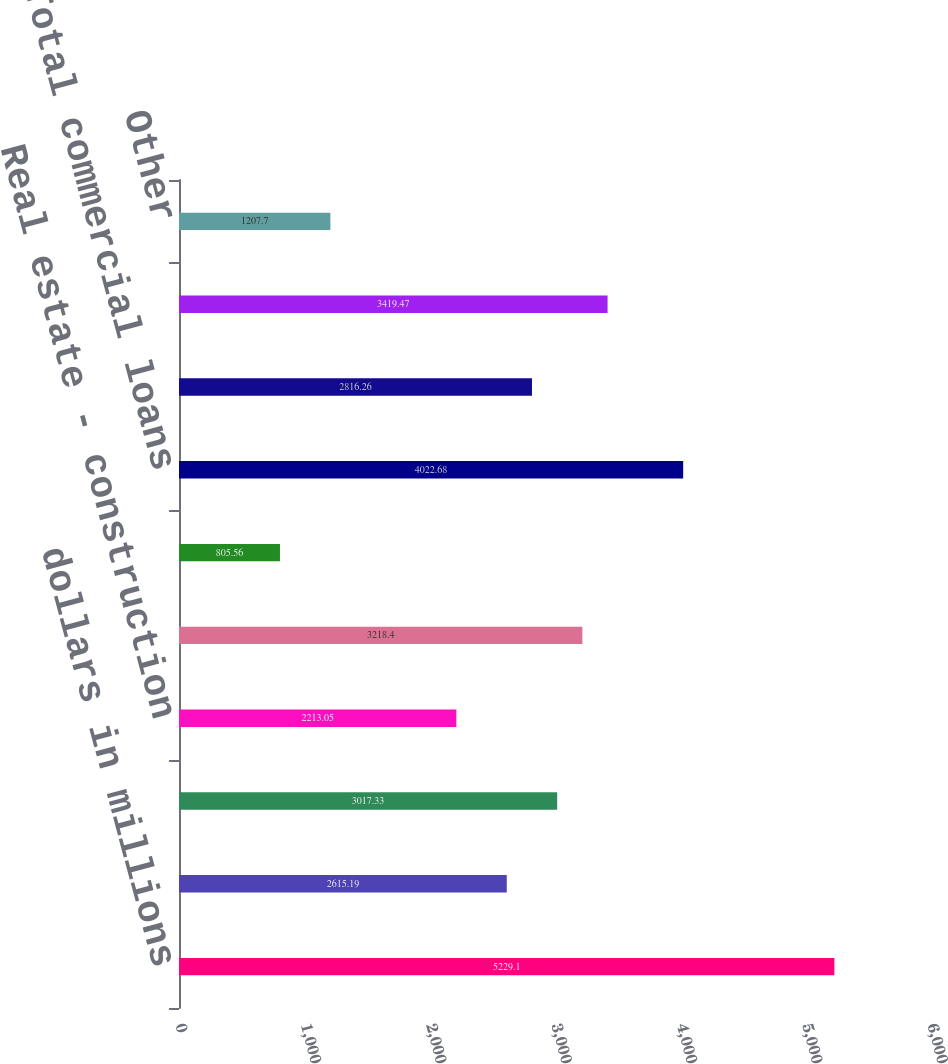<chart> <loc_0><loc_0><loc_500><loc_500><bar_chart><fcel>dollars in millions<fcel>Commercial financial and<fcel>Real estate - commercial<fcel>Real estate - construction<fcel>Total commercial real estate<fcel>Commercial lease financing<fcel>Total commercial loans<fcel>Real estate - residential<fcel>Key Community Bank<fcel>Other<nl><fcel>5229.1<fcel>2615.19<fcel>3017.33<fcel>2213.05<fcel>3218.4<fcel>805.56<fcel>4022.68<fcel>2816.26<fcel>3419.47<fcel>1207.7<nl></chart> 